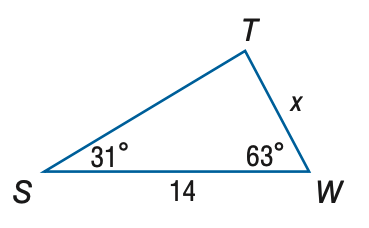Answer the mathemtical geometry problem and directly provide the correct option letter.
Question: Find x. Round to the nearest tenth.
Choices: A: 7.2 B: 8.1 C: 24.2 D: 27.1 A 